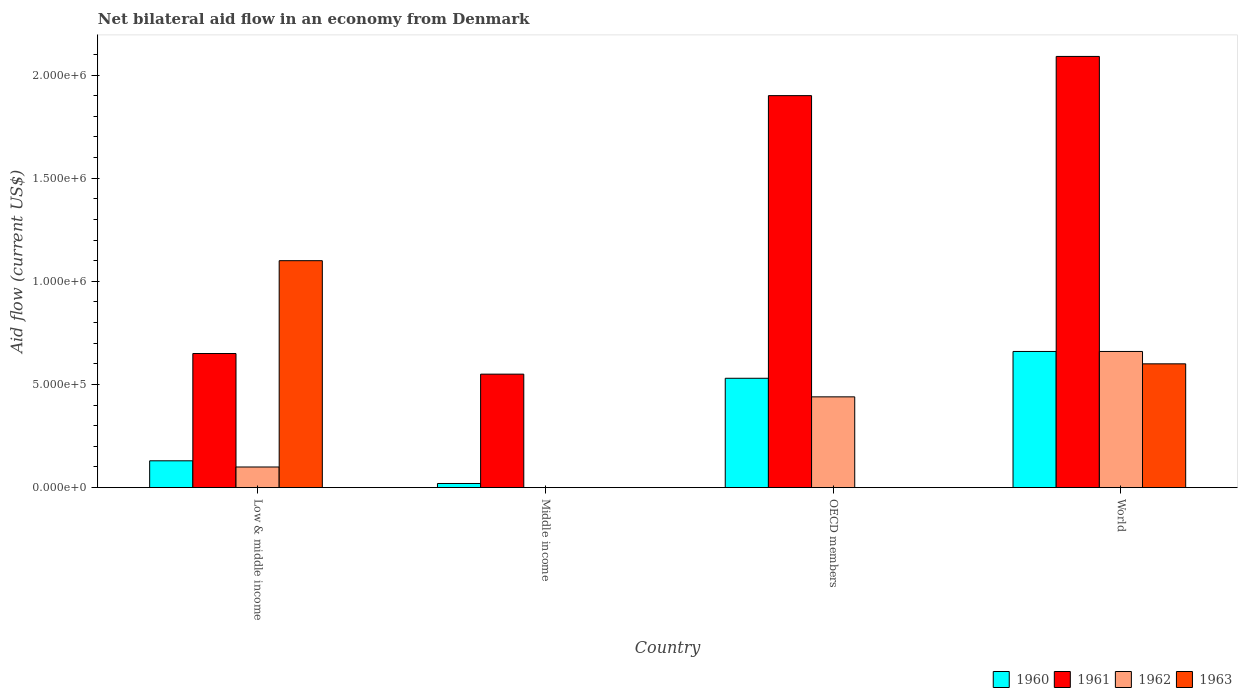How many different coloured bars are there?
Offer a terse response. 4. How many bars are there on the 4th tick from the right?
Offer a very short reply. 4. In how many cases, is the number of bars for a given country not equal to the number of legend labels?
Offer a terse response. 2. What is the net bilateral aid flow in 1961 in Low & middle income?
Provide a succinct answer. 6.50e+05. In which country was the net bilateral aid flow in 1962 maximum?
Give a very brief answer. World. What is the total net bilateral aid flow in 1962 in the graph?
Your response must be concise. 1.20e+06. What is the difference between the net bilateral aid flow in 1962 in World and the net bilateral aid flow in 1961 in OECD members?
Give a very brief answer. -1.24e+06. What is the average net bilateral aid flow in 1961 per country?
Offer a terse response. 1.30e+06. What is the difference between the net bilateral aid flow of/in 1961 and net bilateral aid flow of/in 1963 in World?
Your answer should be compact. 1.49e+06. What is the ratio of the net bilateral aid flow in 1960 in OECD members to that in World?
Your answer should be compact. 0.8. Is the net bilateral aid flow in 1961 in Low & middle income less than that in World?
Keep it short and to the point. Yes. Is the difference between the net bilateral aid flow in 1961 in Low & middle income and World greater than the difference between the net bilateral aid flow in 1963 in Low & middle income and World?
Keep it short and to the point. No. What is the difference between the highest and the second highest net bilateral aid flow in 1962?
Offer a terse response. 5.60e+05. What is the difference between the highest and the lowest net bilateral aid flow in 1961?
Provide a succinct answer. 1.54e+06. Is the sum of the net bilateral aid flow in 1960 in OECD members and World greater than the maximum net bilateral aid flow in 1962 across all countries?
Make the answer very short. Yes. Are all the bars in the graph horizontal?
Your response must be concise. No. Does the graph contain any zero values?
Your answer should be very brief. Yes. Where does the legend appear in the graph?
Offer a very short reply. Bottom right. How many legend labels are there?
Offer a very short reply. 4. What is the title of the graph?
Your answer should be very brief. Net bilateral aid flow in an economy from Denmark. Does "1978" appear as one of the legend labels in the graph?
Give a very brief answer. No. What is the label or title of the Y-axis?
Your answer should be compact. Aid flow (current US$). What is the Aid flow (current US$) in 1961 in Low & middle income?
Provide a succinct answer. 6.50e+05. What is the Aid flow (current US$) of 1963 in Low & middle income?
Offer a very short reply. 1.10e+06. What is the Aid flow (current US$) in 1962 in Middle income?
Provide a short and direct response. 0. What is the Aid flow (current US$) of 1960 in OECD members?
Your response must be concise. 5.30e+05. What is the Aid flow (current US$) in 1961 in OECD members?
Provide a short and direct response. 1.90e+06. What is the Aid flow (current US$) of 1961 in World?
Your response must be concise. 2.09e+06. Across all countries, what is the maximum Aid flow (current US$) in 1961?
Make the answer very short. 2.09e+06. Across all countries, what is the maximum Aid flow (current US$) in 1963?
Your answer should be very brief. 1.10e+06. Across all countries, what is the minimum Aid flow (current US$) of 1960?
Keep it short and to the point. 2.00e+04. Across all countries, what is the minimum Aid flow (current US$) in 1961?
Keep it short and to the point. 5.50e+05. Across all countries, what is the minimum Aid flow (current US$) in 1962?
Your response must be concise. 0. Across all countries, what is the minimum Aid flow (current US$) of 1963?
Your answer should be very brief. 0. What is the total Aid flow (current US$) of 1960 in the graph?
Keep it short and to the point. 1.34e+06. What is the total Aid flow (current US$) in 1961 in the graph?
Keep it short and to the point. 5.19e+06. What is the total Aid flow (current US$) of 1962 in the graph?
Ensure brevity in your answer.  1.20e+06. What is the total Aid flow (current US$) of 1963 in the graph?
Your answer should be compact. 1.70e+06. What is the difference between the Aid flow (current US$) in 1960 in Low & middle income and that in Middle income?
Ensure brevity in your answer.  1.10e+05. What is the difference between the Aid flow (current US$) in 1961 in Low & middle income and that in Middle income?
Provide a succinct answer. 1.00e+05. What is the difference between the Aid flow (current US$) of 1960 in Low & middle income and that in OECD members?
Offer a terse response. -4.00e+05. What is the difference between the Aid flow (current US$) of 1961 in Low & middle income and that in OECD members?
Offer a terse response. -1.25e+06. What is the difference between the Aid flow (current US$) in 1962 in Low & middle income and that in OECD members?
Offer a terse response. -3.40e+05. What is the difference between the Aid flow (current US$) in 1960 in Low & middle income and that in World?
Ensure brevity in your answer.  -5.30e+05. What is the difference between the Aid flow (current US$) in 1961 in Low & middle income and that in World?
Give a very brief answer. -1.44e+06. What is the difference between the Aid flow (current US$) in 1962 in Low & middle income and that in World?
Offer a very short reply. -5.60e+05. What is the difference between the Aid flow (current US$) of 1963 in Low & middle income and that in World?
Provide a short and direct response. 5.00e+05. What is the difference between the Aid flow (current US$) of 1960 in Middle income and that in OECD members?
Provide a short and direct response. -5.10e+05. What is the difference between the Aid flow (current US$) of 1961 in Middle income and that in OECD members?
Your answer should be very brief. -1.35e+06. What is the difference between the Aid flow (current US$) of 1960 in Middle income and that in World?
Give a very brief answer. -6.40e+05. What is the difference between the Aid flow (current US$) of 1961 in Middle income and that in World?
Provide a short and direct response. -1.54e+06. What is the difference between the Aid flow (current US$) in 1960 in OECD members and that in World?
Keep it short and to the point. -1.30e+05. What is the difference between the Aid flow (current US$) in 1961 in OECD members and that in World?
Your answer should be very brief. -1.90e+05. What is the difference between the Aid flow (current US$) in 1960 in Low & middle income and the Aid flow (current US$) in 1961 in Middle income?
Offer a terse response. -4.20e+05. What is the difference between the Aid flow (current US$) in 1960 in Low & middle income and the Aid flow (current US$) in 1961 in OECD members?
Keep it short and to the point. -1.77e+06. What is the difference between the Aid flow (current US$) of 1960 in Low & middle income and the Aid flow (current US$) of 1962 in OECD members?
Give a very brief answer. -3.10e+05. What is the difference between the Aid flow (current US$) in 1961 in Low & middle income and the Aid flow (current US$) in 1962 in OECD members?
Keep it short and to the point. 2.10e+05. What is the difference between the Aid flow (current US$) in 1960 in Low & middle income and the Aid flow (current US$) in 1961 in World?
Provide a short and direct response. -1.96e+06. What is the difference between the Aid flow (current US$) in 1960 in Low & middle income and the Aid flow (current US$) in 1962 in World?
Make the answer very short. -5.30e+05. What is the difference between the Aid flow (current US$) in 1960 in Low & middle income and the Aid flow (current US$) in 1963 in World?
Ensure brevity in your answer.  -4.70e+05. What is the difference between the Aid flow (current US$) of 1961 in Low & middle income and the Aid flow (current US$) of 1963 in World?
Ensure brevity in your answer.  5.00e+04. What is the difference between the Aid flow (current US$) in 1962 in Low & middle income and the Aid flow (current US$) in 1963 in World?
Your answer should be very brief. -5.00e+05. What is the difference between the Aid flow (current US$) in 1960 in Middle income and the Aid flow (current US$) in 1961 in OECD members?
Your answer should be compact. -1.88e+06. What is the difference between the Aid flow (current US$) in 1960 in Middle income and the Aid flow (current US$) in 1962 in OECD members?
Make the answer very short. -4.20e+05. What is the difference between the Aid flow (current US$) of 1961 in Middle income and the Aid flow (current US$) of 1962 in OECD members?
Offer a very short reply. 1.10e+05. What is the difference between the Aid flow (current US$) of 1960 in Middle income and the Aid flow (current US$) of 1961 in World?
Provide a succinct answer. -2.07e+06. What is the difference between the Aid flow (current US$) in 1960 in Middle income and the Aid flow (current US$) in 1962 in World?
Your response must be concise. -6.40e+05. What is the difference between the Aid flow (current US$) of 1960 in Middle income and the Aid flow (current US$) of 1963 in World?
Give a very brief answer. -5.80e+05. What is the difference between the Aid flow (current US$) in 1961 in Middle income and the Aid flow (current US$) in 1962 in World?
Ensure brevity in your answer.  -1.10e+05. What is the difference between the Aid flow (current US$) in 1960 in OECD members and the Aid flow (current US$) in 1961 in World?
Provide a succinct answer. -1.56e+06. What is the difference between the Aid flow (current US$) of 1960 in OECD members and the Aid flow (current US$) of 1963 in World?
Keep it short and to the point. -7.00e+04. What is the difference between the Aid flow (current US$) of 1961 in OECD members and the Aid flow (current US$) of 1962 in World?
Offer a very short reply. 1.24e+06. What is the difference between the Aid flow (current US$) in 1961 in OECD members and the Aid flow (current US$) in 1963 in World?
Your answer should be very brief. 1.30e+06. What is the average Aid flow (current US$) in 1960 per country?
Offer a very short reply. 3.35e+05. What is the average Aid flow (current US$) in 1961 per country?
Your response must be concise. 1.30e+06. What is the average Aid flow (current US$) in 1963 per country?
Your answer should be compact. 4.25e+05. What is the difference between the Aid flow (current US$) in 1960 and Aid flow (current US$) in 1961 in Low & middle income?
Provide a succinct answer. -5.20e+05. What is the difference between the Aid flow (current US$) in 1960 and Aid flow (current US$) in 1962 in Low & middle income?
Your answer should be compact. 3.00e+04. What is the difference between the Aid flow (current US$) of 1960 and Aid flow (current US$) of 1963 in Low & middle income?
Your answer should be compact. -9.70e+05. What is the difference between the Aid flow (current US$) in 1961 and Aid flow (current US$) in 1962 in Low & middle income?
Offer a very short reply. 5.50e+05. What is the difference between the Aid flow (current US$) of 1961 and Aid flow (current US$) of 1963 in Low & middle income?
Offer a terse response. -4.50e+05. What is the difference between the Aid flow (current US$) of 1962 and Aid flow (current US$) of 1963 in Low & middle income?
Give a very brief answer. -1.00e+06. What is the difference between the Aid flow (current US$) of 1960 and Aid flow (current US$) of 1961 in Middle income?
Give a very brief answer. -5.30e+05. What is the difference between the Aid flow (current US$) in 1960 and Aid flow (current US$) in 1961 in OECD members?
Give a very brief answer. -1.37e+06. What is the difference between the Aid flow (current US$) of 1961 and Aid flow (current US$) of 1962 in OECD members?
Your response must be concise. 1.46e+06. What is the difference between the Aid flow (current US$) in 1960 and Aid flow (current US$) in 1961 in World?
Make the answer very short. -1.43e+06. What is the difference between the Aid flow (current US$) in 1960 and Aid flow (current US$) in 1962 in World?
Your response must be concise. 0. What is the difference between the Aid flow (current US$) of 1961 and Aid flow (current US$) of 1962 in World?
Make the answer very short. 1.43e+06. What is the difference between the Aid flow (current US$) of 1961 and Aid flow (current US$) of 1963 in World?
Provide a succinct answer. 1.49e+06. What is the difference between the Aid flow (current US$) of 1962 and Aid flow (current US$) of 1963 in World?
Ensure brevity in your answer.  6.00e+04. What is the ratio of the Aid flow (current US$) in 1961 in Low & middle income to that in Middle income?
Give a very brief answer. 1.18. What is the ratio of the Aid flow (current US$) of 1960 in Low & middle income to that in OECD members?
Offer a terse response. 0.25. What is the ratio of the Aid flow (current US$) of 1961 in Low & middle income to that in OECD members?
Your answer should be compact. 0.34. What is the ratio of the Aid flow (current US$) in 1962 in Low & middle income to that in OECD members?
Keep it short and to the point. 0.23. What is the ratio of the Aid flow (current US$) in 1960 in Low & middle income to that in World?
Make the answer very short. 0.2. What is the ratio of the Aid flow (current US$) of 1961 in Low & middle income to that in World?
Make the answer very short. 0.31. What is the ratio of the Aid flow (current US$) of 1962 in Low & middle income to that in World?
Provide a short and direct response. 0.15. What is the ratio of the Aid flow (current US$) in 1963 in Low & middle income to that in World?
Keep it short and to the point. 1.83. What is the ratio of the Aid flow (current US$) of 1960 in Middle income to that in OECD members?
Give a very brief answer. 0.04. What is the ratio of the Aid flow (current US$) in 1961 in Middle income to that in OECD members?
Offer a very short reply. 0.29. What is the ratio of the Aid flow (current US$) of 1960 in Middle income to that in World?
Your answer should be compact. 0.03. What is the ratio of the Aid flow (current US$) in 1961 in Middle income to that in World?
Your answer should be very brief. 0.26. What is the ratio of the Aid flow (current US$) in 1960 in OECD members to that in World?
Provide a short and direct response. 0.8. What is the ratio of the Aid flow (current US$) in 1962 in OECD members to that in World?
Provide a succinct answer. 0.67. What is the difference between the highest and the second highest Aid flow (current US$) in 1960?
Provide a succinct answer. 1.30e+05. What is the difference between the highest and the second highest Aid flow (current US$) in 1961?
Your answer should be compact. 1.90e+05. What is the difference between the highest and the lowest Aid flow (current US$) in 1960?
Give a very brief answer. 6.40e+05. What is the difference between the highest and the lowest Aid flow (current US$) of 1961?
Make the answer very short. 1.54e+06. What is the difference between the highest and the lowest Aid flow (current US$) in 1962?
Give a very brief answer. 6.60e+05. What is the difference between the highest and the lowest Aid flow (current US$) of 1963?
Your response must be concise. 1.10e+06. 